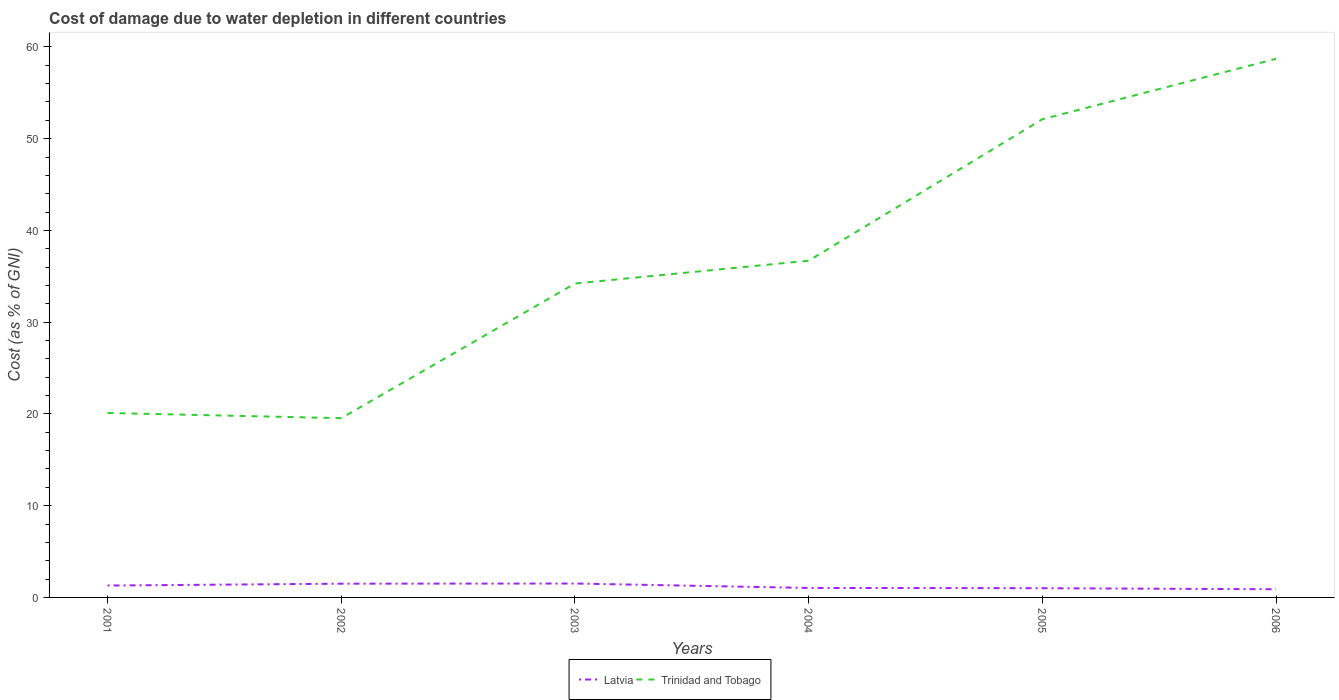Does the line corresponding to Latvia intersect with the line corresponding to Trinidad and Tobago?
Your answer should be very brief. No. Across all years, what is the maximum cost of damage caused due to water depletion in Latvia?
Offer a terse response. 0.89. What is the total cost of damage caused due to water depletion in Latvia in the graph?
Provide a succinct answer. 0.46. What is the difference between the highest and the second highest cost of damage caused due to water depletion in Trinidad and Tobago?
Your response must be concise. 39.17. How many years are there in the graph?
Your response must be concise. 6. Does the graph contain grids?
Ensure brevity in your answer.  No. What is the title of the graph?
Your answer should be very brief. Cost of damage due to water depletion in different countries. Does "Bulgaria" appear as one of the legend labels in the graph?
Provide a short and direct response. No. What is the label or title of the Y-axis?
Your answer should be very brief. Cost (as % of GNI). What is the Cost (as % of GNI) of Latvia in 2001?
Keep it short and to the point. 1.29. What is the Cost (as % of GNI) in Trinidad and Tobago in 2001?
Your answer should be very brief. 20.11. What is the Cost (as % of GNI) in Latvia in 2002?
Offer a very short reply. 1.5. What is the Cost (as % of GNI) of Trinidad and Tobago in 2002?
Keep it short and to the point. 19.54. What is the Cost (as % of GNI) of Latvia in 2003?
Offer a terse response. 1.52. What is the Cost (as % of GNI) of Trinidad and Tobago in 2003?
Offer a terse response. 34.22. What is the Cost (as % of GNI) of Latvia in 2004?
Offer a very short reply. 1.03. What is the Cost (as % of GNI) in Trinidad and Tobago in 2004?
Offer a very short reply. 36.7. What is the Cost (as % of GNI) of Latvia in 2005?
Give a very brief answer. 1. What is the Cost (as % of GNI) of Trinidad and Tobago in 2005?
Your response must be concise. 52.12. What is the Cost (as % of GNI) of Latvia in 2006?
Provide a succinct answer. 0.89. What is the Cost (as % of GNI) of Trinidad and Tobago in 2006?
Offer a very short reply. 58.71. Across all years, what is the maximum Cost (as % of GNI) in Latvia?
Your answer should be compact. 1.52. Across all years, what is the maximum Cost (as % of GNI) in Trinidad and Tobago?
Provide a succinct answer. 58.71. Across all years, what is the minimum Cost (as % of GNI) in Latvia?
Provide a succinct answer. 0.89. Across all years, what is the minimum Cost (as % of GNI) of Trinidad and Tobago?
Give a very brief answer. 19.54. What is the total Cost (as % of GNI) in Latvia in the graph?
Give a very brief answer. 7.24. What is the total Cost (as % of GNI) of Trinidad and Tobago in the graph?
Offer a very short reply. 221.39. What is the difference between the Cost (as % of GNI) of Latvia in 2001 and that in 2002?
Offer a terse response. -0.2. What is the difference between the Cost (as % of GNI) in Trinidad and Tobago in 2001 and that in 2002?
Give a very brief answer. 0.57. What is the difference between the Cost (as % of GNI) in Latvia in 2001 and that in 2003?
Provide a succinct answer. -0.22. What is the difference between the Cost (as % of GNI) in Trinidad and Tobago in 2001 and that in 2003?
Give a very brief answer. -14.11. What is the difference between the Cost (as % of GNI) of Latvia in 2001 and that in 2004?
Ensure brevity in your answer.  0.26. What is the difference between the Cost (as % of GNI) in Trinidad and Tobago in 2001 and that in 2004?
Your answer should be very brief. -16.6. What is the difference between the Cost (as % of GNI) in Latvia in 2001 and that in 2005?
Your response must be concise. 0.29. What is the difference between the Cost (as % of GNI) of Trinidad and Tobago in 2001 and that in 2005?
Provide a succinct answer. -32.02. What is the difference between the Cost (as % of GNI) in Latvia in 2001 and that in 2006?
Offer a terse response. 0.4. What is the difference between the Cost (as % of GNI) in Trinidad and Tobago in 2001 and that in 2006?
Offer a terse response. -38.6. What is the difference between the Cost (as % of GNI) of Latvia in 2002 and that in 2003?
Your response must be concise. -0.02. What is the difference between the Cost (as % of GNI) in Trinidad and Tobago in 2002 and that in 2003?
Ensure brevity in your answer.  -14.68. What is the difference between the Cost (as % of GNI) of Latvia in 2002 and that in 2004?
Give a very brief answer. 0.46. What is the difference between the Cost (as % of GNI) of Trinidad and Tobago in 2002 and that in 2004?
Offer a terse response. -17.17. What is the difference between the Cost (as % of GNI) in Latvia in 2002 and that in 2005?
Give a very brief answer. 0.49. What is the difference between the Cost (as % of GNI) of Trinidad and Tobago in 2002 and that in 2005?
Offer a very short reply. -32.59. What is the difference between the Cost (as % of GNI) in Latvia in 2002 and that in 2006?
Offer a very short reply. 0.61. What is the difference between the Cost (as % of GNI) of Trinidad and Tobago in 2002 and that in 2006?
Your answer should be very brief. -39.17. What is the difference between the Cost (as % of GNI) in Latvia in 2003 and that in 2004?
Provide a short and direct response. 0.48. What is the difference between the Cost (as % of GNI) of Trinidad and Tobago in 2003 and that in 2004?
Provide a succinct answer. -2.49. What is the difference between the Cost (as % of GNI) in Latvia in 2003 and that in 2005?
Make the answer very short. 0.51. What is the difference between the Cost (as % of GNI) of Trinidad and Tobago in 2003 and that in 2005?
Make the answer very short. -17.91. What is the difference between the Cost (as % of GNI) of Latvia in 2003 and that in 2006?
Provide a succinct answer. 0.62. What is the difference between the Cost (as % of GNI) in Trinidad and Tobago in 2003 and that in 2006?
Give a very brief answer. -24.49. What is the difference between the Cost (as % of GNI) in Latvia in 2004 and that in 2005?
Make the answer very short. 0.03. What is the difference between the Cost (as % of GNI) of Trinidad and Tobago in 2004 and that in 2005?
Make the answer very short. -15.42. What is the difference between the Cost (as % of GNI) in Latvia in 2004 and that in 2006?
Keep it short and to the point. 0.14. What is the difference between the Cost (as % of GNI) of Trinidad and Tobago in 2004 and that in 2006?
Give a very brief answer. -22.01. What is the difference between the Cost (as % of GNI) of Latvia in 2005 and that in 2006?
Provide a short and direct response. 0.11. What is the difference between the Cost (as % of GNI) in Trinidad and Tobago in 2005 and that in 2006?
Provide a short and direct response. -6.59. What is the difference between the Cost (as % of GNI) in Latvia in 2001 and the Cost (as % of GNI) in Trinidad and Tobago in 2002?
Offer a terse response. -18.24. What is the difference between the Cost (as % of GNI) of Latvia in 2001 and the Cost (as % of GNI) of Trinidad and Tobago in 2003?
Offer a very short reply. -32.92. What is the difference between the Cost (as % of GNI) in Latvia in 2001 and the Cost (as % of GNI) in Trinidad and Tobago in 2004?
Provide a succinct answer. -35.41. What is the difference between the Cost (as % of GNI) of Latvia in 2001 and the Cost (as % of GNI) of Trinidad and Tobago in 2005?
Your response must be concise. -50.83. What is the difference between the Cost (as % of GNI) in Latvia in 2001 and the Cost (as % of GNI) in Trinidad and Tobago in 2006?
Ensure brevity in your answer.  -57.42. What is the difference between the Cost (as % of GNI) of Latvia in 2002 and the Cost (as % of GNI) of Trinidad and Tobago in 2003?
Your response must be concise. -32.72. What is the difference between the Cost (as % of GNI) in Latvia in 2002 and the Cost (as % of GNI) in Trinidad and Tobago in 2004?
Your answer should be very brief. -35.21. What is the difference between the Cost (as % of GNI) in Latvia in 2002 and the Cost (as % of GNI) in Trinidad and Tobago in 2005?
Keep it short and to the point. -50.62. What is the difference between the Cost (as % of GNI) in Latvia in 2002 and the Cost (as % of GNI) in Trinidad and Tobago in 2006?
Your answer should be compact. -57.21. What is the difference between the Cost (as % of GNI) of Latvia in 2003 and the Cost (as % of GNI) of Trinidad and Tobago in 2004?
Your answer should be very brief. -35.19. What is the difference between the Cost (as % of GNI) in Latvia in 2003 and the Cost (as % of GNI) in Trinidad and Tobago in 2005?
Ensure brevity in your answer.  -50.61. What is the difference between the Cost (as % of GNI) in Latvia in 2003 and the Cost (as % of GNI) in Trinidad and Tobago in 2006?
Ensure brevity in your answer.  -57.19. What is the difference between the Cost (as % of GNI) in Latvia in 2004 and the Cost (as % of GNI) in Trinidad and Tobago in 2005?
Make the answer very short. -51.09. What is the difference between the Cost (as % of GNI) in Latvia in 2004 and the Cost (as % of GNI) in Trinidad and Tobago in 2006?
Your answer should be very brief. -57.68. What is the difference between the Cost (as % of GNI) in Latvia in 2005 and the Cost (as % of GNI) in Trinidad and Tobago in 2006?
Give a very brief answer. -57.71. What is the average Cost (as % of GNI) in Latvia per year?
Ensure brevity in your answer.  1.21. What is the average Cost (as % of GNI) in Trinidad and Tobago per year?
Your answer should be very brief. 36.9. In the year 2001, what is the difference between the Cost (as % of GNI) in Latvia and Cost (as % of GNI) in Trinidad and Tobago?
Offer a very short reply. -18.81. In the year 2002, what is the difference between the Cost (as % of GNI) in Latvia and Cost (as % of GNI) in Trinidad and Tobago?
Give a very brief answer. -18.04. In the year 2003, what is the difference between the Cost (as % of GNI) in Latvia and Cost (as % of GNI) in Trinidad and Tobago?
Your answer should be very brief. -32.7. In the year 2004, what is the difference between the Cost (as % of GNI) in Latvia and Cost (as % of GNI) in Trinidad and Tobago?
Your answer should be compact. -35.67. In the year 2005, what is the difference between the Cost (as % of GNI) in Latvia and Cost (as % of GNI) in Trinidad and Tobago?
Your answer should be very brief. -51.12. In the year 2006, what is the difference between the Cost (as % of GNI) in Latvia and Cost (as % of GNI) in Trinidad and Tobago?
Ensure brevity in your answer.  -57.82. What is the ratio of the Cost (as % of GNI) of Latvia in 2001 to that in 2002?
Ensure brevity in your answer.  0.86. What is the ratio of the Cost (as % of GNI) of Trinidad and Tobago in 2001 to that in 2002?
Make the answer very short. 1.03. What is the ratio of the Cost (as % of GNI) of Latvia in 2001 to that in 2003?
Offer a very short reply. 0.85. What is the ratio of the Cost (as % of GNI) of Trinidad and Tobago in 2001 to that in 2003?
Provide a short and direct response. 0.59. What is the ratio of the Cost (as % of GNI) in Latvia in 2001 to that in 2004?
Give a very brief answer. 1.25. What is the ratio of the Cost (as % of GNI) in Trinidad and Tobago in 2001 to that in 2004?
Give a very brief answer. 0.55. What is the ratio of the Cost (as % of GNI) of Latvia in 2001 to that in 2005?
Your answer should be very brief. 1.29. What is the ratio of the Cost (as % of GNI) of Trinidad and Tobago in 2001 to that in 2005?
Keep it short and to the point. 0.39. What is the ratio of the Cost (as % of GNI) in Latvia in 2001 to that in 2006?
Provide a succinct answer. 1.45. What is the ratio of the Cost (as % of GNI) of Trinidad and Tobago in 2001 to that in 2006?
Offer a very short reply. 0.34. What is the ratio of the Cost (as % of GNI) in Trinidad and Tobago in 2002 to that in 2003?
Provide a succinct answer. 0.57. What is the ratio of the Cost (as % of GNI) of Latvia in 2002 to that in 2004?
Your answer should be compact. 1.45. What is the ratio of the Cost (as % of GNI) in Trinidad and Tobago in 2002 to that in 2004?
Your response must be concise. 0.53. What is the ratio of the Cost (as % of GNI) in Latvia in 2002 to that in 2005?
Give a very brief answer. 1.49. What is the ratio of the Cost (as % of GNI) in Trinidad and Tobago in 2002 to that in 2005?
Offer a terse response. 0.37. What is the ratio of the Cost (as % of GNI) in Latvia in 2002 to that in 2006?
Your answer should be very brief. 1.68. What is the ratio of the Cost (as % of GNI) of Trinidad and Tobago in 2002 to that in 2006?
Your response must be concise. 0.33. What is the ratio of the Cost (as % of GNI) in Latvia in 2003 to that in 2004?
Your answer should be compact. 1.47. What is the ratio of the Cost (as % of GNI) of Trinidad and Tobago in 2003 to that in 2004?
Provide a succinct answer. 0.93. What is the ratio of the Cost (as % of GNI) of Latvia in 2003 to that in 2005?
Provide a short and direct response. 1.51. What is the ratio of the Cost (as % of GNI) in Trinidad and Tobago in 2003 to that in 2005?
Offer a terse response. 0.66. What is the ratio of the Cost (as % of GNI) of Latvia in 2003 to that in 2006?
Make the answer very short. 1.7. What is the ratio of the Cost (as % of GNI) in Trinidad and Tobago in 2003 to that in 2006?
Give a very brief answer. 0.58. What is the ratio of the Cost (as % of GNI) in Latvia in 2004 to that in 2005?
Offer a very short reply. 1.03. What is the ratio of the Cost (as % of GNI) of Trinidad and Tobago in 2004 to that in 2005?
Give a very brief answer. 0.7. What is the ratio of the Cost (as % of GNI) of Latvia in 2004 to that in 2006?
Make the answer very short. 1.16. What is the ratio of the Cost (as % of GNI) in Trinidad and Tobago in 2004 to that in 2006?
Offer a very short reply. 0.63. What is the ratio of the Cost (as % of GNI) of Latvia in 2005 to that in 2006?
Ensure brevity in your answer.  1.13. What is the ratio of the Cost (as % of GNI) of Trinidad and Tobago in 2005 to that in 2006?
Provide a short and direct response. 0.89. What is the difference between the highest and the second highest Cost (as % of GNI) in Latvia?
Make the answer very short. 0.02. What is the difference between the highest and the second highest Cost (as % of GNI) in Trinidad and Tobago?
Make the answer very short. 6.59. What is the difference between the highest and the lowest Cost (as % of GNI) in Latvia?
Your answer should be very brief. 0.62. What is the difference between the highest and the lowest Cost (as % of GNI) of Trinidad and Tobago?
Ensure brevity in your answer.  39.17. 